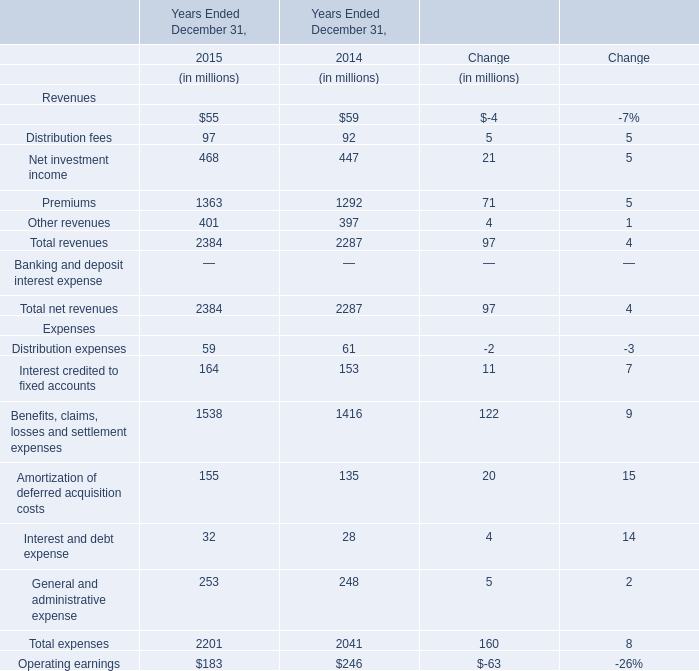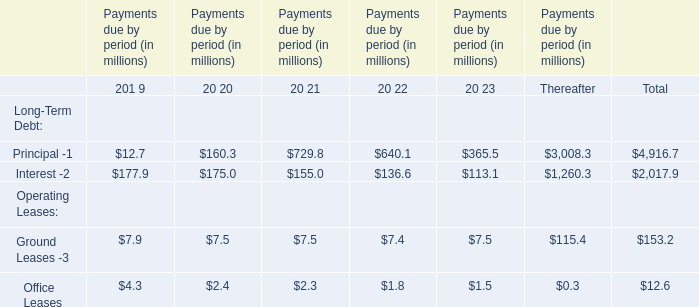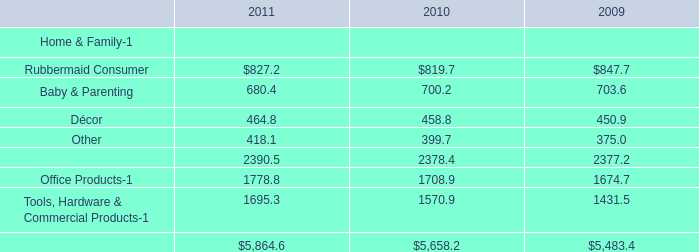What is the growing rate of Total expenses in the years with the least Total net revenues? 
Computations: ((2201 - 2041) / 2041)
Answer: 0.07839. 